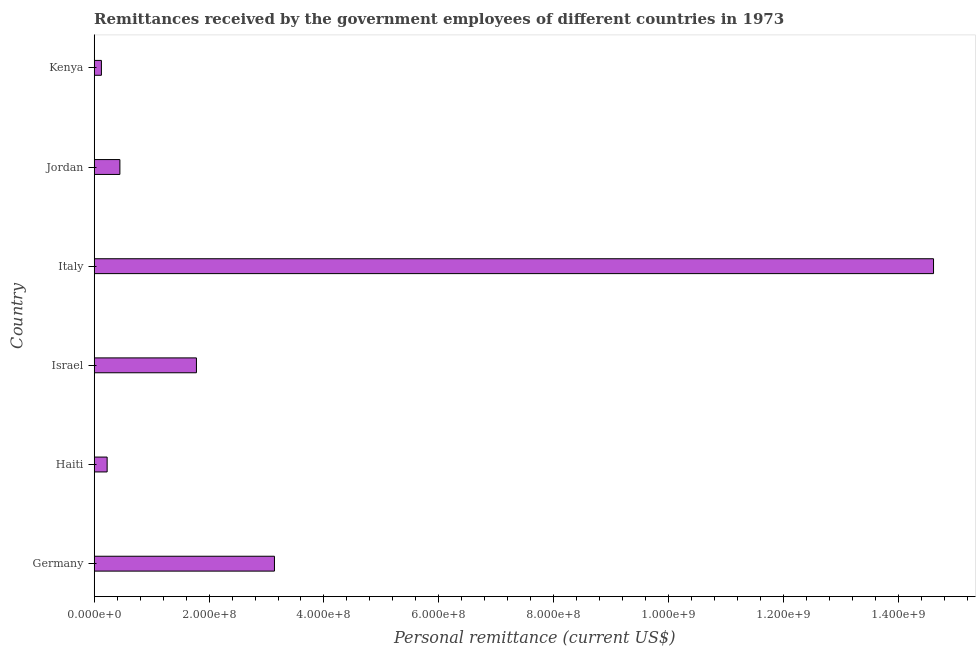Does the graph contain any zero values?
Give a very brief answer. No. Does the graph contain grids?
Keep it short and to the point. No. What is the title of the graph?
Ensure brevity in your answer.  Remittances received by the government employees of different countries in 1973. What is the label or title of the X-axis?
Your answer should be compact. Personal remittance (current US$). What is the label or title of the Y-axis?
Offer a terse response. Country. What is the personal remittances in Jordan?
Make the answer very short. 4.47e+07. Across all countries, what is the maximum personal remittances?
Ensure brevity in your answer.  1.46e+09. Across all countries, what is the minimum personal remittances?
Keep it short and to the point. 1.25e+07. In which country was the personal remittances minimum?
Offer a terse response. Kenya. What is the sum of the personal remittances?
Provide a short and direct response. 2.03e+09. What is the difference between the personal remittances in Italy and Jordan?
Give a very brief answer. 1.42e+09. What is the average personal remittances per country?
Provide a succinct answer. 3.39e+08. What is the median personal remittances?
Ensure brevity in your answer.  1.11e+08. In how many countries, is the personal remittances greater than 720000000 US$?
Your answer should be very brief. 1. What is the ratio of the personal remittances in Israel to that in Jordan?
Offer a terse response. 3.98. Is the difference between the personal remittances in Italy and Kenya greater than the difference between any two countries?
Ensure brevity in your answer.  Yes. What is the difference between the highest and the second highest personal remittances?
Ensure brevity in your answer.  1.15e+09. Is the sum of the personal remittances in Germany and Italy greater than the maximum personal remittances across all countries?
Make the answer very short. Yes. What is the difference between the highest and the lowest personal remittances?
Keep it short and to the point. 1.45e+09. How many bars are there?
Keep it short and to the point. 6. How many countries are there in the graph?
Provide a short and direct response. 6. What is the difference between two consecutive major ticks on the X-axis?
Give a very brief answer. 2.00e+08. Are the values on the major ticks of X-axis written in scientific E-notation?
Your answer should be very brief. Yes. What is the Personal remittance (current US$) in Germany?
Your response must be concise. 3.14e+08. What is the Personal remittance (current US$) of Haiti?
Offer a terse response. 2.25e+07. What is the Personal remittance (current US$) in Israel?
Your response must be concise. 1.78e+08. What is the Personal remittance (current US$) in Italy?
Make the answer very short. 1.46e+09. What is the Personal remittance (current US$) of Jordan?
Ensure brevity in your answer.  4.47e+07. What is the Personal remittance (current US$) of Kenya?
Make the answer very short. 1.25e+07. What is the difference between the Personal remittance (current US$) in Germany and Haiti?
Make the answer very short. 2.91e+08. What is the difference between the Personal remittance (current US$) in Germany and Israel?
Offer a very short reply. 1.36e+08. What is the difference between the Personal remittance (current US$) in Germany and Italy?
Your response must be concise. -1.15e+09. What is the difference between the Personal remittance (current US$) in Germany and Jordan?
Give a very brief answer. 2.69e+08. What is the difference between the Personal remittance (current US$) in Germany and Kenya?
Your response must be concise. 3.01e+08. What is the difference between the Personal remittance (current US$) in Haiti and Israel?
Make the answer very short. -1.55e+08. What is the difference between the Personal remittance (current US$) in Haiti and Italy?
Offer a very short reply. -1.44e+09. What is the difference between the Personal remittance (current US$) in Haiti and Jordan?
Your answer should be very brief. -2.22e+07. What is the difference between the Personal remittance (current US$) in Haiti and Kenya?
Offer a very short reply. 1.00e+07. What is the difference between the Personal remittance (current US$) in Israel and Italy?
Give a very brief answer. -1.28e+09. What is the difference between the Personal remittance (current US$) in Israel and Jordan?
Your response must be concise. 1.33e+08. What is the difference between the Personal remittance (current US$) in Israel and Kenya?
Your response must be concise. 1.65e+08. What is the difference between the Personal remittance (current US$) in Italy and Jordan?
Offer a very short reply. 1.42e+09. What is the difference between the Personal remittance (current US$) in Italy and Kenya?
Provide a short and direct response. 1.45e+09. What is the difference between the Personal remittance (current US$) in Jordan and Kenya?
Your answer should be compact. 3.22e+07. What is the ratio of the Personal remittance (current US$) in Germany to that in Haiti?
Ensure brevity in your answer.  13.92. What is the ratio of the Personal remittance (current US$) in Germany to that in Israel?
Provide a succinct answer. 1.76. What is the ratio of the Personal remittance (current US$) in Germany to that in Italy?
Ensure brevity in your answer.  0.21. What is the ratio of the Personal remittance (current US$) in Germany to that in Jordan?
Ensure brevity in your answer.  7.01. What is the ratio of the Personal remittance (current US$) in Germany to that in Kenya?
Your answer should be compact. 25.02. What is the ratio of the Personal remittance (current US$) in Haiti to that in Israel?
Your answer should be compact. 0.13. What is the ratio of the Personal remittance (current US$) in Haiti to that in Italy?
Keep it short and to the point. 0.01. What is the ratio of the Personal remittance (current US$) in Haiti to that in Jordan?
Offer a very short reply. 0.5. What is the ratio of the Personal remittance (current US$) in Haiti to that in Kenya?
Keep it short and to the point. 1.8. What is the ratio of the Personal remittance (current US$) in Israel to that in Italy?
Give a very brief answer. 0.12. What is the ratio of the Personal remittance (current US$) in Israel to that in Jordan?
Your answer should be very brief. 3.98. What is the ratio of the Personal remittance (current US$) in Israel to that in Kenya?
Give a very brief answer. 14.2. What is the ratio of the Personal remittance (current US$) in Italy to that in Jordan?
Provide a short and direct response. 32.66. What is the ratio of the Personal remittance (current US$) in Italy to that in Kenya?
Your response must be concise. 116.52. What is the ratio of the Personal remittance (current US$) in Jordan to that in Kenya?
Your answer should be compact. 3.57. 